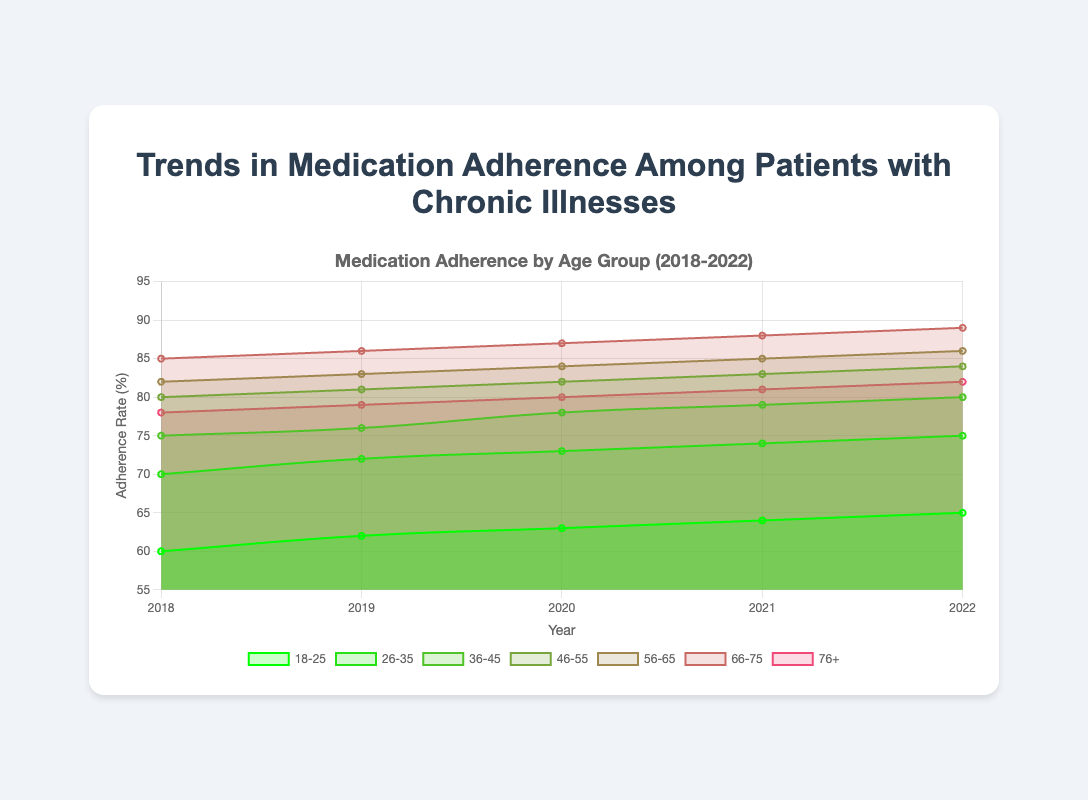What is the title of the chart? The title of the chart can be found at the top of the figure. By looking at the figure, we can see it directly without any calculation or debate.
Answer: Trends in Medication Adherence Among Patients with Chronic Illnesses Which age group had the highest adherence rate in 2022? To find the highest adherence rate in 2022, look at the adherence rates of all age groups for that year and identify the maximum value. Age group 66-75 had the highest adherence rate of 89% in 2022.
Answer: 66-75 What is the average medication adherence rate for the age group 46-55 over the years 2018 to 2022? First, find the adherence rates for the age group 46-55 in the years 2018, 2019, 2020, 2021, and 2022. These are 80, 81, 82, 83, and 84 respectively. Add these values and divide by the number of years: (80 + 81 + 82 + 83 + 84) / 5 = 410 / 5 = 82
Answer: 82 By how much did the adherence rate for the age group 18-25 increase from 2018 to 2022? Find the adherence rates for the age group 18-25 in 2018 and 2022, which are 60 and 65 respectively. Subtract the 2018 value from the 2022 value: 65 - 60 = 5
Answer: 5 Which year showed the highest overall adherence rate for the age group 36-45? Look at the adherence rates for the age group 36-45 across all years, which are 75, 76, 78, 79, and 80 for the years 2018, 2019, 2020, 2021, and 2022 respectively. The highest value is 80 in the year 2022.
Answer: 2022 What is the median adherence rate for the age group 26-35 from 2018 to 2022? The adherence rates for the age group 26-35 from 2018 to 2022 are 70, 72, 73, 74, and 75. To find the median, order the numbers and find the middle value. The ordered values are 70, 72, 73, 74, and 75, and the median is 73.
Answer: 73 Which age group had the least increase in medication adherence from 2018 to 2022? Calculate the increase in adherence rates for each age group from 2018 to 2022. The increases are: 
- 18-25: 65 - 60 = 5
- 26-35: 75 - 70 = 5
- 36-45: 80 - 75 = 5
- 46-55: 84 - 80 = 4
- 56-65: 86 - 82 = 4
- 66-75: 89 - 85 = 4
- 76+: 82 - 78 = 4
The least increase is 4%, shared by the age groups 46-55, 56-65, 66-75, and 76+.
Answer: 46-55, 56-65, 66-75, 76+ How did the adherence rate trend for the age group 76+ from 2018 to 2022? Observe the adherence rates for the age group 76+ across the years 2018 to 2022, which are 78, 79, 80, 81, and 82 respectively. There is a consistent upward trend each year.
Answer: Upward trend 